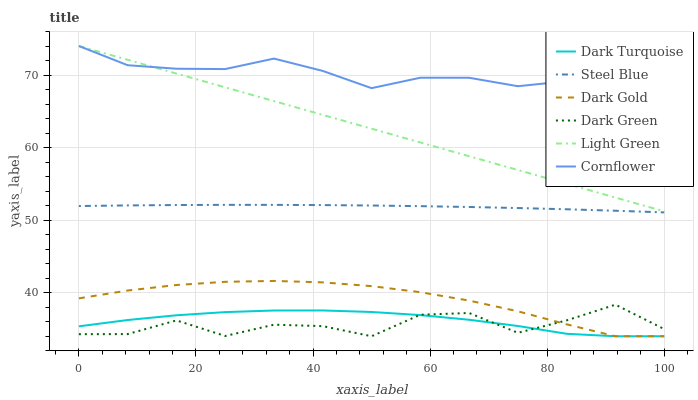Does Dark Green have the minimum area under the curve?
Answer yes or no. Yes. Does Cornflower have the maximum area under the curve?
Answer yes or no. Yes. Does Dark Gold have the minimum area under the curve?
Answer yes or no. No. Does Dark Gold have the maximum area under the curve?
Answer yes or no. No. Is Light Green the smoothest?
Answer yes or no. Yes. Is Dark Green the roughest?
Answer yes or no. Yes. Is Dark Gold the smoothest?
Answer yes or no. No. Is Dark Gold the roughest?
Answer yes or no. No. Does Dark Gold have the lowest value?
Answer yes or no. Yes. Does Steel Blue have the lowest value?
Answer yes or no. No. Does Light Green have the highest value?
Answer yes or no. Yes. Does Dark Gold have the highest value?
Answer yes or no. No. Is Dark Green less than Cornflower?
Answer yes or no. Yes. Is Cornflower greater than Dark Green?
Answer yes or no. Yes. Does Dark Gold intersect Dark Green?
Answer yes or no. Yes. Is Dark Gold less than Dark Green?
Answer yes or no. No. Is Dark Gold greater than Dark Green?
Answer yes or no. No. Does Dark Green intersect Cornflower?
Answer yes or no. No. 